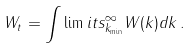<formula> <loc_0><loc_0><loc_500><loc_500>W _ { t } = \int \lim i t s _ { k _ { \min } } ^ { \infty } W ( k ) d k \, .</formula> 